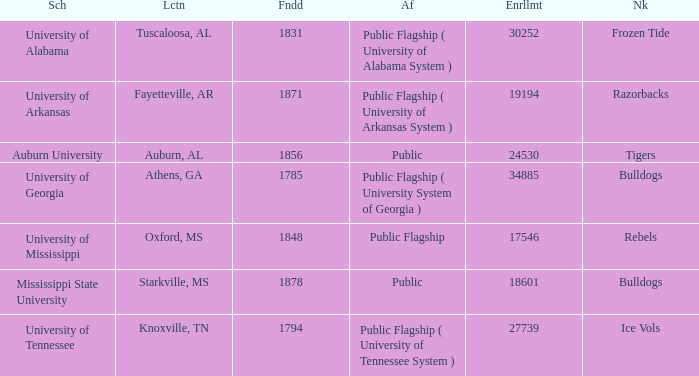What is the maximum enrollment of the schools? 34885.0. 